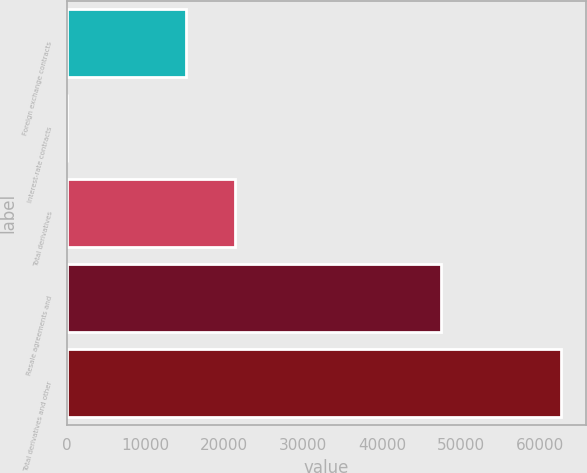Convert chart. <chart><loc_0><loc_0><loc_500><loc_500><bar_chart><fcel>Foreign exchange contracts<fcel>Interest-rate contracts<fcel>Total derivatives<fcel>Resale agreements and<fcel>Total derivatives and other<nl><fcel>15135<fcel>77<fcel>21397.5<fcel>47488<fcel>62702<nl></chart> 